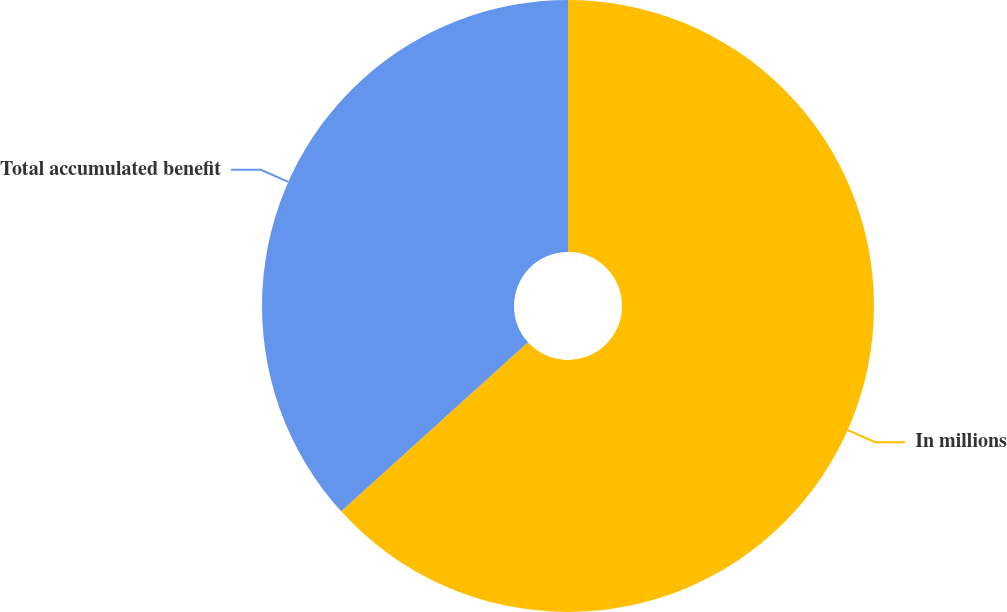Convert chart to OTSL. <chart><loc_0><loc_0><loc_500><loc_500><pie_chart><fcel>In millions<fcel>Total accumulated benefit<nl><fcel>63.29%<fcel>36.71%<nl></chart> 